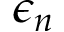Convert formula to latex. <formula><loc_0><loc_0><loc_500><loc_500>\epsilon _ { n }</formula> 